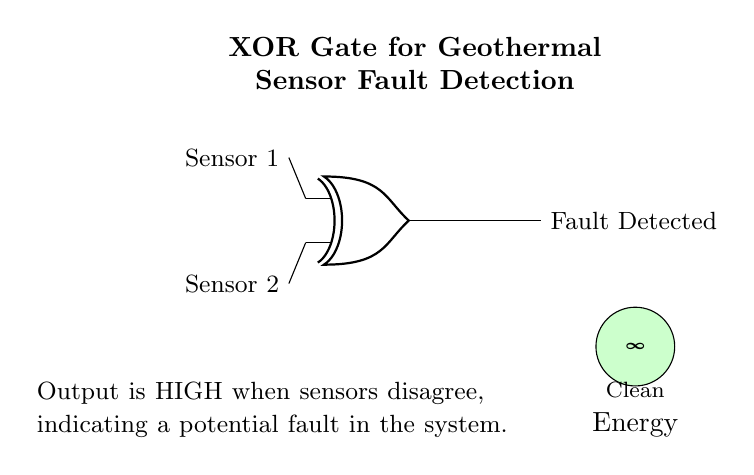What is the output label of the circuit? The output label of the circuit is "Fault Detected", which indicates the condition monitored by the XOR gate has been triggered by input from the sensors.
Answer: Fault Detected What type of gate is used in this circuit? The circuit uses an XOR (exclusive OR) gate, which is specifically designed to output a high signal only when the inputs differ.
Answer: XOR gate How many sensors are indicated in the circuit? The circuit diagram indicates two sensors: Sensor 1 and Sensor 2, which are the inputs to the XOR gate.
Answer: Two sensors What condition causes the output to be HIGH? The output will be HIGH when the inputs from the sensors disagree, which corresponds to one sensor reporting a fault while the other does not.
Answer: Sensors disagree What is the significance of the green symbol in the diagram? The green symbol represents clean energy, which emphasizes the circuit's application in monitoring a geothermal power plant that supports renewable energy sources.
Answer: Clean energy What role do the sensors play in this circuit? The sensors serve as inputs to the XOR gate, providing vital operational data that allows the detection of faults in the geothermal power plant system.
Answer: Inputs 